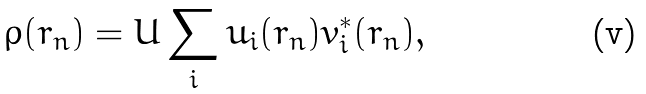Convert formula to latex. <formula><loc_0><loc_0><loc_500><loc_500>\rho ( { r } _ { n } ) = U \sum _ { i } u _ { i } ( { r } _ { n } ) v _ { i } ^ { * } ( { r } _ { n } ) ,</formula> 